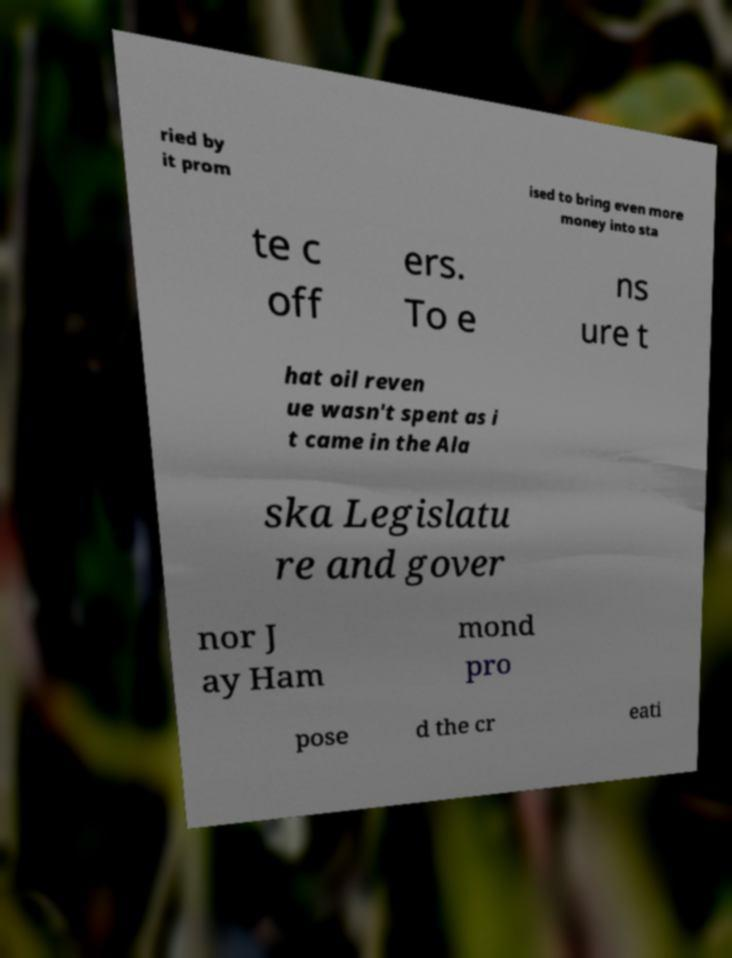Please read and relay the text visible in this image. What does it say? ried by it prom ised to bring even more money into sta te c off ers. To e ns ure t hat oil reven ue wasn't spent as i t came in the Ala ska Legislatu re and gover nor J ay Ham mond pro pose d the cr eati 